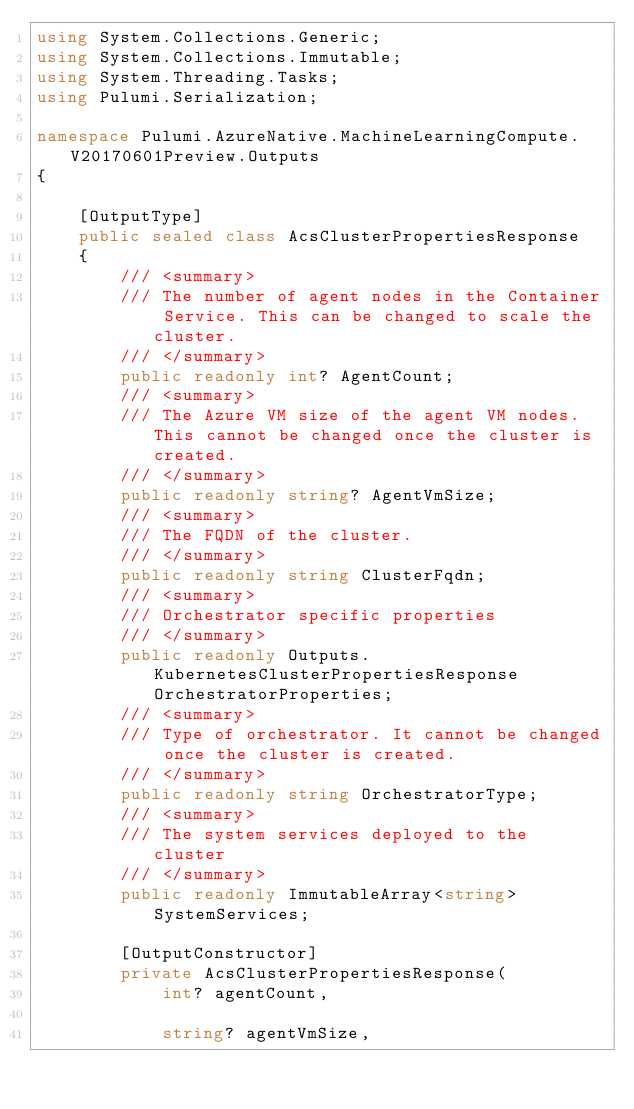<code> <loc_0><loc_0><loc_500><loc_500><_C#_>using System.Collections.Generic;
using System.Collections.Immutable;
using System.Threading.Tasks;
using Pulumi.Serialization;

namespace Pulumi.AzureNative.MachineLearningCompute.V20170601Preview.Outputs
{

    [OutputType]
    public sealed class AcsClusterPropertiesResponse
    {
        /// <summary>
        /// The number of agent nodes in the Container Service. This can be changed to scale the cluster.
        /// </summary>
        public readonly int? AgentCount;
        /// <summary>
        /// The Azure VM size of the agent VM nodes. This cannot be changed once the cluster is created.
        /// </summary>
        public readonly string? AgentVmSize;
        /// <summary>
        /// The FQDN of the cluster. 
        /// </summary>
        public readonly string ClusterFqdn;
        /// <summary>
        /// Orchestrator specific properties
        /// </summary>
        public readonly Outputs.KubernetesClusterPropertiesResponse OrchestratorProperties;
        /// <summary>
        /// Type of orchestrator. It cannot be changed once the cluster is created.
        /// </summary>
        public readonly string OrchestratorType;
        /// <summary>
        /// The system services deployed to the cluster
        /// </summary>
        public readonly ImmutableArray<string> SystemServices;

        [OutputConstructor]
        private AcsClusterPropertiesResponse(
            int? agentCount,

            string? agentVmSize,
</code> 